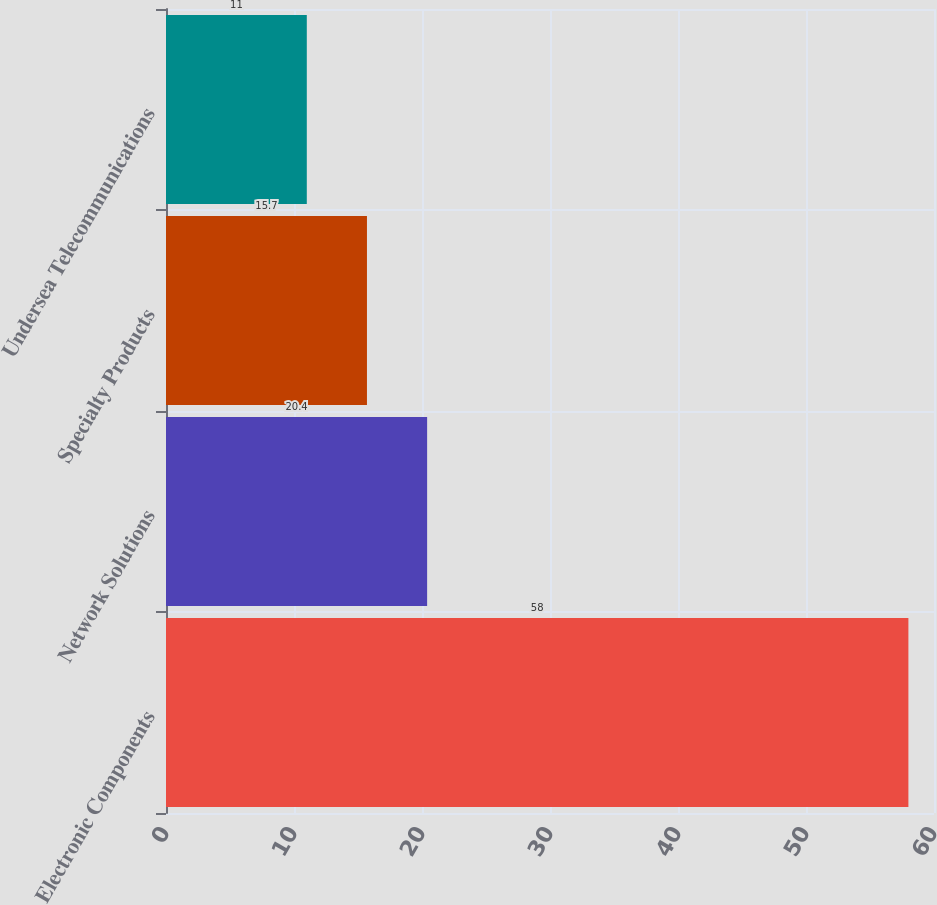Convert chart to OTSL. <chart><loc_0><loc_0><loc_500><loc_500><bar_chart><fcel>Electronic Components<fcel>Network Solutions<fcel>Specialty Products<fcel>Undersea Telecommunications<nl><fcel>58<fcel>20.4<fcel>15.7<fcel>11<nl></chart> 